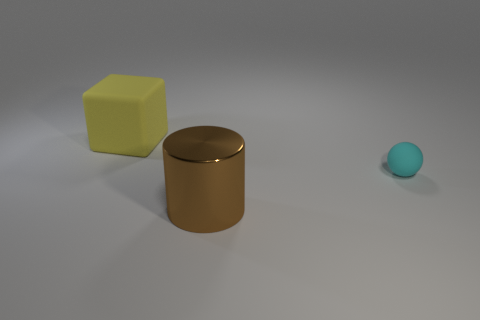Subtract all yellow spheres. Subtract all red blocks. How many spheres are left? 1 Add 1 big objects. How many objects exist? 4 Subtract all cylinders. How many objects are left? 2 Add 1 rubber spheres. How many rubber spheres exist? 2 Subtract 1 brown cylinders. How many objects are left? 2 Subtract all large gray balls. Subtract all cubes. How many objects are left? 2 Add 2 cyan matte balls. How many cyan matte balls are left? 3 